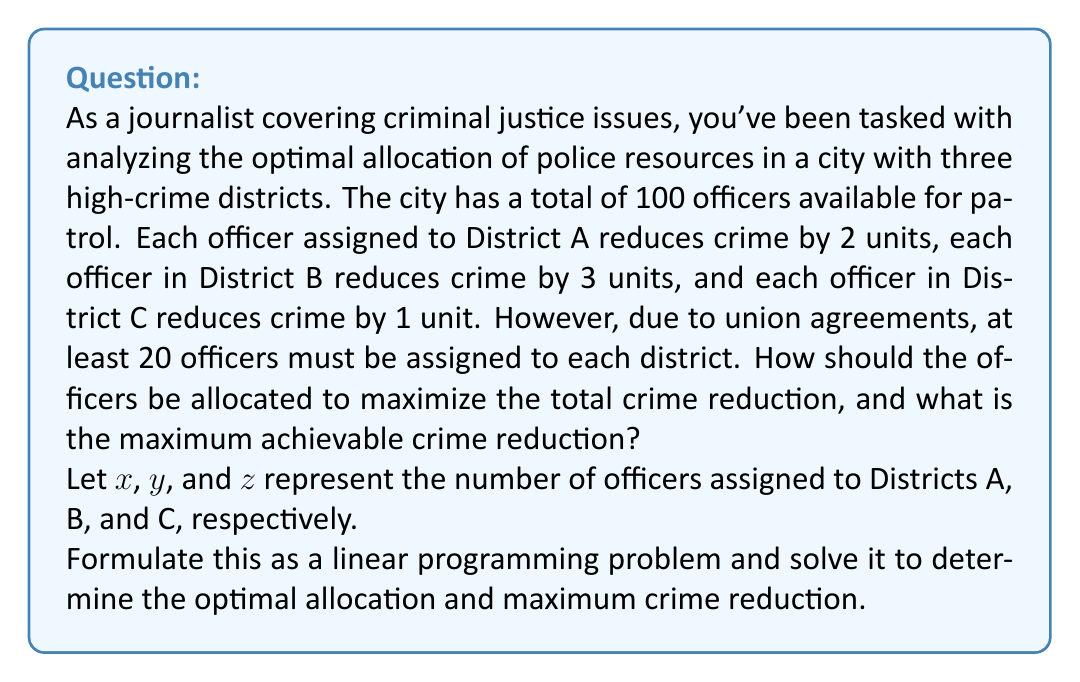Could you help me with this problem? To solve this problem, we'll use linear programming. Let's formulate the problem and then solve it step by step.

1. Objective function:
   We want to maximize the total crime reduction:
   $$\text{Maximize } 2x + 3y + z$$

2. Constraints:
   a) Total number of officers: $x + y + z = 100$
   b) Minimum officers per district: $x \geq 20$, $y \geq 20$, $z \geq 20$
   c) Non-negativity: $x, y, z \geq 0$ (implied by constraint b)

3. Solving the linear programming problem:
   We can use the simplex method or graphical method, but for this problem, we can deduce the solution logically:

   a) We need to assign as many officers as possible to District B since it has the highest crime reduction rate (3 units per officer).
   b) After that, we should assign officers to District A (2 units per officer).
   c) We only assign the minimum required officers to District C (1 unit per officer) since it has the lowest impact.

4. Optimal allocation:
   a) Assign 20 officers to District C (minimum required)
   b) Assign 20 officers to District A (minimum required)
   c) Assign the remaining 60 officers to District B

5. Calculating the maximum crime reduction:
   $$\text{Crime Reduction} = 2(20) + 3(60) + 1(20) = 40 + 180 + 20 = 240$$

Therefore, the optimal allocation is 20 officers to District A, 60 officers to District B, and 20 officers to District C, resulting in a maximum crime reduction of 240 units.
Answer: Optimal allocation: 20 officers to District A, 60 officers to District B, and 20 officers to District C.
Maximum achievable crime reduction: 240 units. 